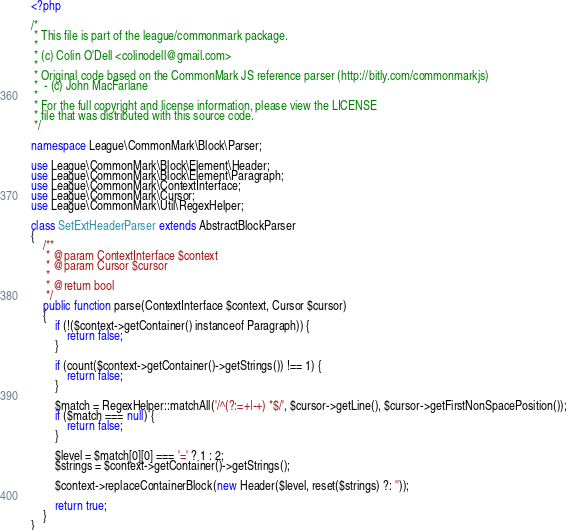Convert code to text. <code><loc_0><loc_0><loc_500><loc_500><_PHP_><?php

/*
 * This file is part of the league/commonmark package.
 *
 * (c) Colin O'Dell <colinodell@gmail.com>
 *
 * Original code based on the CommonMark JS reference parser (http://bitly.com/commonmarkjs)
 *  - (c) John MacFarlane
 *
 * For the full copyright and license information, please view the LICENSE
 * file that was distributed with this source code.
 */

namespace League\CommonMark\Block\Parser;

use League\CommonMark\Block\Element\Header;
use League\CommonMark\Block\Element\Paragraph;
use League\CommonMark\ContextInterface;
use League\CommonMark\Cursor;
use League\CommonMark\Util\RegexHelper;

class SetExtHeaderParser extends AbstractBlockParser
{
    /**
     * @param ContextInterface $context
     * @param Cursor $cursor
     *
     * @return bool
     */
    public function parse(ContextInterface $context, Cursor $cursor)
    {
        if (!($context->getContainer() instanceof Paragraph)) {
            return false;
        }

        if (count($context->getContainer()->getStrings()) !== 1) {
            return false;
        }

        $match = RegexHelper::matchAll('/^(?:=+|-+) *$/', $cursor->getLine(), $cursor->getFirstNonSpacePosition());
        if ($match === null) {
            return false;
        }

        $level = $match[0][0] === '=' ? 1 : 2;
        $strings = $context->getContainer()->getStrings();

        $context->replaceContainerBlock(new Header($level, reset($strings) ?: ''));

        return true;
    }
}
</code> 